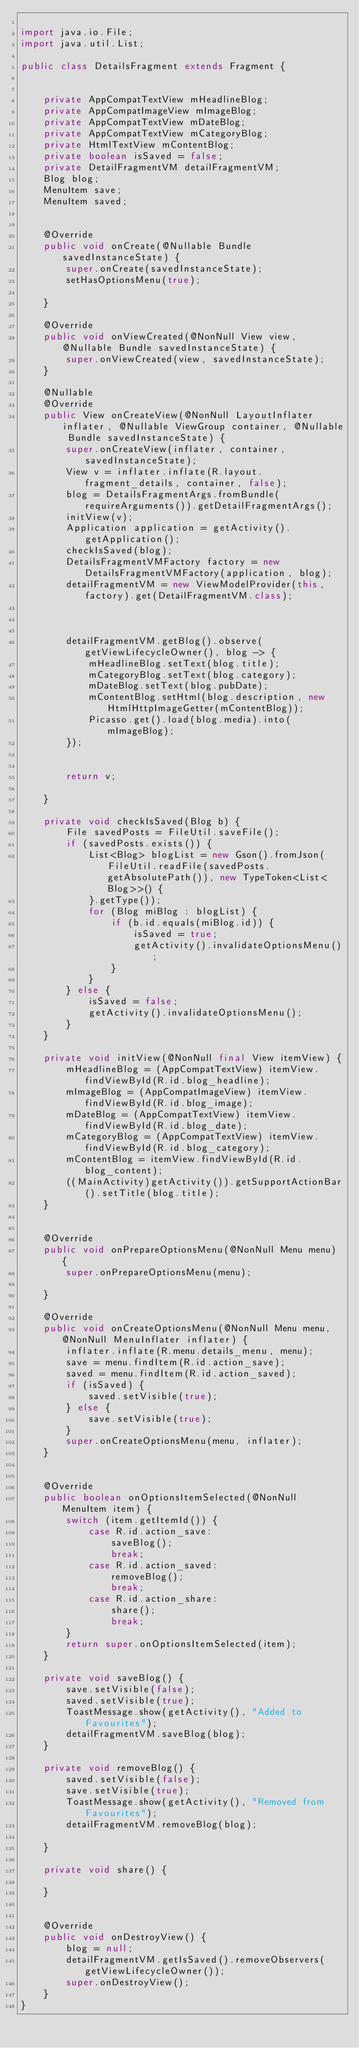Convert code to text. <code><loc_0><loc_0><loc_500><loc_500><_Java_>
import java.io.File;
import java.util.List;

public class DetailsFragment extends Fragment {


    private AppCompatTextView mHeadlineBlog;
    private AppCompatImageView mImageBlog;
    private AppCompatTextView mDateBlog;
    private AppCompatTextView mCategoryBlog;
    private HtmlTextView mContentBlog;
    private boolean isSaved = false;
    private DetailFragmentVM detailFragmentVM;
    Blog blog;
    MenuItem save;
    MenuItem saved;


    @Override
    public void onCreate(@Nullable Bundle savedInstanceState) {
        super.onCreate(savedInstanceState);
        setHasOptionsMenu(true);

    }

    @Override
    public void onViewCreated(@NonNull View view, @Nullable Bundle savedInstanceState) {
        super.onViewCreated(view, savedInstanceState);
    }

    @Nullable
    @Override
    public View onCreateView(@NonNull LayoutInflater inflater, @Nullable ViewGroup container, @Nullable Bundle savedInstanceState) {
        super.onCreateView(inflater, container, savedInstanceState);
        View v = inflater.inflate(R.layout.fragment_details, container, false);
        blog = DetailsFragmentArgs.fromBundle(requireArguments()).getDetailFragmentArgs();
        initView(v);
        Application application = getActivity().getApplication();
        checkIsSaved(blog);
        DetailsFragmentVMFactory factory = new DetailsFragmentVMFactory(application, blog);
        detailFragmentVM = new ViewModelProvider(this, factory).get(DetailFragmentVM.class);



        detailFragmentVM.getBlog().observe(getViewLifecycleOwner(), blog -> {
            mHeadlineBlog.setText(blog.title);
            mCategoryBlog.setText(blog.category);
            mDateBlog.setText(blog.pubDate);
            mContentBlog.setHtml(blog.description, new HtmlHttpImageGetter(mContentBlog));
            Picasso.get().load(blog.media).into(mImageBlog);
        });


        return v;

    }

    private void checkIsSaved(Blog b) {
        File savedPosts = FileUtil.saveFile();
        if (savedPosts.exists()) {
            List<Blog> blogList = new Gson().fromJson(FileUtil.readFile(savedPosts.getAbsolutePath()), new TypeToken<List<Blog>>() {
            }.getType());
            for (Blog miBlog : blogList) {
                if (b.id.equals(miBlog.id)) {
                    isSaved = true;
                    getActivity().invalidateOptionsMenu();
                }
            }
        } else {
            isSaved = false;
            getActivity().invalidateOptionsMenu();
        }
    }

    private void initView(@NonNull final View itemView) {
        mHeadlineBlog = (AppCompatTextView) itemView.findViewById(R.id.blog_headline);
        mImageBlog = (AppCompatImageView) itemView.findViewById(R.id.blog_image);
        mDateBlog = (AppCompatTextView) itemView.findViewById(R.id.blog_date);
        mCategoryBlog = (AppCompatTextView) itemView.findViewById(R.id.blog_category);
        mContentBlog = itemView.findViewById(R.id.blog_content);
        ((MainActivity)getActivity()).getSupportActionBar().setTitle(blog.title);
    }


    @Override
    public void onPrepareOptionsMenu(@NonNull Menu menu) {
        super.onPrepareOptionsMenu(menu);

    }

    @Override
    public void onCreateOptionsMenu(@NonNull Menu menu, @NonNull MenuInflater inflater) {
        inflater.inflate(R.menu.details_menu, menu);
        save = menu.findItem(R.id.action_save);
        saved = menu.findItem(R.id.action_saved);
        if (isSaved) {
            saved.setVisible(true);
        } else {
            save.setVisible(true);
        }
        super.onCreateOptionsMenu(menu, inflater);
    }


    @Override
    public boolean onOptionsItemSelected(@NonNull MenuItem item) {
        switch (item.getItemId()) {
            case R.id.action_save:
                saveBlog();
                break;
            case R.id.action_saved:
                removeBlog();
                break;
            case R.id.action_share:
                share();
                break;
        }
        return super.onOptionsItemSelected(item);
    }

    private void saveBlog() {
        save.setVisible(false);
        saved.setVisible(true);
        ToastMessage.show(getActivity(), "Added to Favourites");
        detailFragmentVM.saveBlog(blog);
    }

    private void removeBlog() {
        saved.setVisible(false);
        save.setVisible(true);
        ToastMessage.show(getActivity(), "Removed from Favourites");
        detailFragmentVM.removeBlog(blog);

    }

    private void share() {

    }


    @Override
    public void onDestroyView() {
        blog = null;
        detailFragmentVM.getIsSaved().removeObservers(getViewLifecycleOwner());
        super.onDestroyView();
    }
}
</code> 